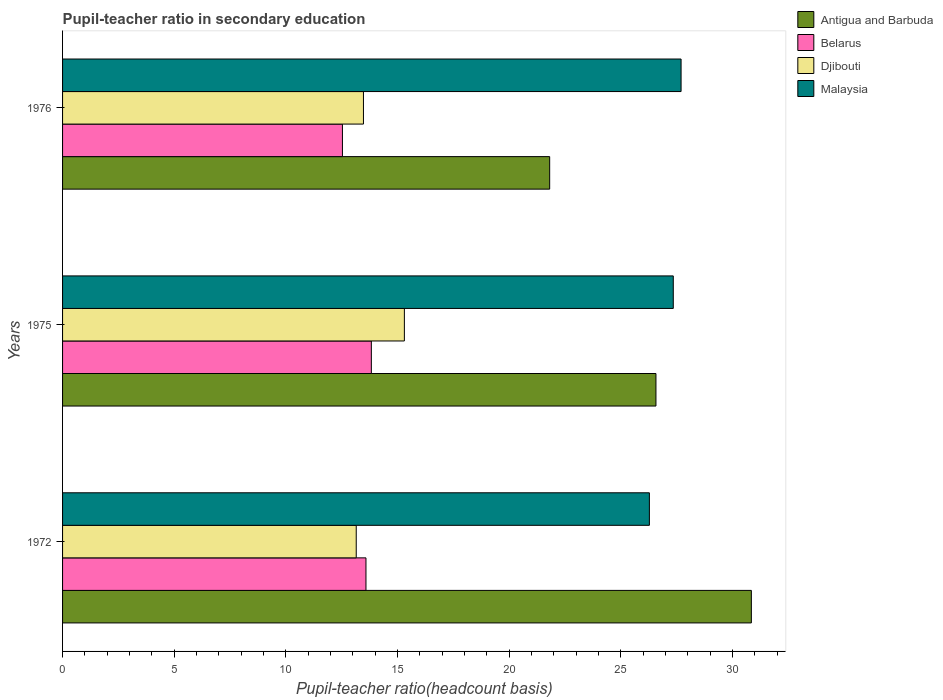Are the number of bars per tick equal to the number of legend labels?
Keep it short and to the point. Yes. Are the number of bars on each tick of the Y-axis equal?
Give a very brief answer. Yes. How many bars are there on the 2nd tick from the top?
Provide a succinct answer. 4. How many bars are there on the 3rd tick from the bottom?
Your response must be concise. 4. What is the label of the 2nd group of bars from the top?
Offer a very short reply. 1975. What is the pupil-teacher ratio in secondary education in Belarus in 1975?
Your answer should be compact. 13.83. Across all years, what is the maximum pupil-teacher ratio in secondary education in Malaysia?
Make the answer very short. 27.7. Across all years, what is the minimum pupil-teacher ratio in secondary education in Malaysia?
Give a very brief answer. 26.28. In which year was the pupil-teacher ratio in secondary education in Malaysia maximum?
Ensure brevity in your answer.  1976. What is the total pupil-teacher ratio in secondary education in Djibouti in the graph?
Provide a short and direct response. 41.93. What is the difference between the pupil-teacher ratio in secondary education in Malaysia in 1975 and that in 1976?
Offer a very short reply. -0.35. What is the difference between the pupil-teacher ratio in secondary education in Antigua and Barbuda in 1975 and the pupil-teacher ratio in secondary education in Djibouti in 1972?
Ensure brevity in your answer.  13.42. What is the average pupil-teacher ratio in secondary education in Malaysia per year?
Provide a short and direct response. 27.11. In the year 1975, what is the difference between the pupil-teacher ratio in secondary education in Belarus and pupil-teacher ratio in secondary education in Djibouti?
Your answer should be very brief. -1.48. What is the ratio of the pupil-teacher ratio in secondary education in Antigua and Barbuda in 1972 to that in 1976?
Offer a very short reply. 1.41. What is the difference between the highest and the second highest pupil-teacher ratio in secondary education in Antigua and Barbuda?
Keep it short and to the point. 4.27. What is the difference between the highest and the lowest pupil-teacher ratio in secondary education in Belarus?
Keep it short and to the point. 1.29. Is the sum of the pupil-teacher ratio in secondary education in Belarus in 1972 and 1975 greater than the maximum pupil-teacher ratio in secondary education in Antigua and Barbuda across all years?
Ensure brevity in your answer.  No. Is it the case that in every year, the sum of the pupil-teacher ratio in secondary education in Antigua and Barbuda and pupil-teacher ratio in secondary education in Malaysia is greater than the sum of pupil-teacher ratio in secondary education in Belarus and pupil-teacher ratio in secondary education in Djibouti?
Offer a very short reply. Yes. What does the 4th bar from the top in 1972 represents?
Make the answer very short. Antigua and Barbuda. What does the 1st bar from the bottom in 1975 represents?
Provide a succinct answer. Antigua and Barbuda. How many bars are there?
Your response must be concise. 12. What is the difference between two consecutive major ticks on the X-axis?
Provide a short and direct response. 5. Are the values on the major ticks of X-axis written in scientific E-notation?
Keep it short and to the point. No. Does the graph contain any zero values?
Offer a very short reply. No. How many legend labels are there?
Your response must be concise. 4. What is the title of the graph?
Provide a short and direct response. Pupil-teacher ratio in secondary education. Does "Uruguay" appear as one of the legend labels in the graph?
Keep it short and to the point. No. What is the label or title of the X-axis?
Your answer should be very brief. Pupil-teacher ratio(headcount basis). What is the Pupil-teacher ratio(headcount basis) of Antigua and Barbuda in 1972?
Provide a succinct answer. 30.84. What is the Pupil-teacher ratio(headcount basis) of Belarus in 1972?
Provide a short and direct response. 13.59. What is the Pupil-teacher ratio(headcount basis) of Djibouti in 1972?
Your answer should be very brief. 13.15. What is the Pupil-teacher ratio(headcount basis) in Malaysia in 1972?
Provide a succinct answer. 26.28. What is the Pupil-teacher ratio(headcount basis) in Antigua and Barbuda in 1975?
Your answer should be very brief. 26.57. What is the Pupil-teacher ratio(headcount basis) in Belarus in 1975?
Offer a terse response. 13.83. What is the Pupil-teacher ratio(headcount basis) of Djibouti in 1975?
Provide a short and direct response. 15.3. What is the Pupil-teacher ratio(headcount basis) of Malaysia in 1975?
Your answer should be very brief. 27.35. What is the Pupil-teacher ratio(headcount basis) of Antigua and Barbuda in 1976?
Give a very brief answer. 21.81. What is the Pupil-teacher ratio(headcount basis) of Belarus in 1976?
Provide a short and direct response. 12.53. What is the Pupil-teacher ratio(headcount basis) of Djibouti in 1976?
Ensure brevity in your answer.  13.47. What is the Pupil-teacher ratio(headcount basis) in Malaysia in 1976?
Provide a short and direct response. 27.7. Across all years, what is the maximum Pupil-teacher ratio(headcount basis) in Antigua and Barbuda?
Ensure brevity in your answer.  30.84. Across all years, what is the maximum Pupil-teacher ratio(headcount basis) of Belarus?
Your answer should be very brief. 13.83. Across all years, what is the maximum Pupil-teacher ratio(headcount basis) in Djibouti?
Your answer should be very brief. 15.3. Across all years, what is the maximum Pupil-teacher ratio(headcount basis) of Malaysia?
Make the answer very short. 27.7. Across all years, what is the minimum Pupil-teacher ratio(headcount basis) of Antigua and Barbuda?
Provide a short and direct response. 21.81. Across all years, what is the minimum Pupil-teacher ratio(headcount basis) of Belarus?
Ensure brevity in your answer.  12.53. Across all years, what is the minimum Pupil-teacher ratio(headcount basis) of Djibouti?
Give a very brief answer. 13.15. Across all years, what is the minimum Pupil-teacher ratio(headcount basis) in Malaysia?
Keep it short and to the point. 26.28. What is the total Pupil-teacher ratio(headcount basis) in Antigua and Barbuda in the graph?
Offer a very short reply. 79.22. What is the total Pupil-teacher ratio(headcount basis) of Belarus in the graph?
Provide a succinct answer. 39.94. What is the total Pupil-teacher ratio(headcount basis) in Djibouti in the graph?
Your answer should be very brief. 41.93. What is the total Pupil-teacher ratio(headcount basis) in Malaysia in the graph?
Your answer should be compact. 81.32. What is the difference between the Pupil-teacher ratio(headcount basis) of Antigua and Barbuda in 1972 and that in 1975?
Offer a very short reply. 4.27. What is the difference between the Pupil-teacher ratio(headcount basis) in Belarus in 1972 and that in 1975?
Give a very brief answer. -0.24. What is the difference between the Pupil-teacher ratio(headcount basis) of Djibouti in 1972 and that in 1975?
Your answer should be compact. -2.15. What is the difference between the Pupil-teacher ratio(headcount basis) in Malaysia in 1972 and that in 1975?
Make the answer very short. -1.07. What is the difference between the Pupil-teacher ratio(headcount basis) of Antigua and Barbuda in 1972 and that in 1976?
Provide a succinct answer. 9.03. What is the difference between the Pupil-teacher ratio(headcount basis) of Belarus in 1972 and that in 1976?
Provide a succinct answer. 1.05. What is the difference between the Pupil-teacher ratio(headcount basis) of Djibouti in 1972 and that in 1976?
Make the answer very short. -0.32. What is the difference between the Pupil-teacher ratio(headcount basis) in Malaysia in 1972 and that in 1976?
Keep it short and to the point. -1.42. What is the difference between the Pupil-teacher ratio(headcount basis) of Antigua and Barbuda in 1975 and that in 1976?
Your answer should be very brief. 4.76. What is the difference between the Pupil-teacher ratio(headcount basis) of Belarus in 1975 and that in 1976?
Your answer should be compact. 1.29. What is the difference between the Pupil-teacher ratio(headcount basis) of Djibouti in 1975 and that in 1976?
Ensure brevity in your answer.  1.83. What is the difference between the Pupil-teacher ratio(headcount basis) of Malaysia in 1975 and that in 1976?
Your response must be concise. -0.35. What is the difference between the Pupil-teacher ratio(headcount basis) in Antigua and Barbuda in 1972 and the Pupil-teacher ratio(headcount basis) in Belarus in 1975?
Offer a terse response. 17.02. What is the difference between the Pupil-teacher ratio(headcount basis) in Antigua and Barbuda in 1972 and the Pupil-teacher ratio(headcount basis) in Djibouti in 1975?
Provide a succinct answer. 15.54. What is the difference between the Pupil-teacher ratio(headcount basis) in Antigua and Barbuda in 1972 and the Pupil-teacher ratio(headcount basis) in Malaysia in 1975?
Provide a short and direct response. 3.5. What is the difference between the Pupil-teacher ratio(headcount basis) of Belarus in 1972 and the Pupil-teacher ratio(headcount basis) of Djibouti in 1975?
Provide a succinct answer. -1.72. What is the difference between the Pupil-teacher ratio(headcount basis) in Belarus in 1972 and the Pupil-teacher ratio(headcount basis) in Malaysia in 1975?
Provide a succinct answer. -13.76. What is the difference between the Pupil-teacher ratio(headcount basis) in Djibouti in 1972 and the Pupil-teacher ratio(headcount basis) in Malaysia in 1975?
Your response must be concise. -14.2. What is the difference between the Pupil-teacher ratio(headcount basis) in Antigua and Barbuda in 1972 and the Pupil-teacher ratio(headcount basis) in Belarus in 1976?
Offer a very short reply. 18.31. What is the difference between the Pupil-teacher ratio(headcount basis) of Antigua and Barbuda in 1972 and the Pupil-teacher ratio(headcount basis) of Djibouti in 1976?
Give a very brief answer. 17.37. What is the difference between the Pupil-teacher ratio(headcount basis) of Antigua and Barbuda in 1972 and the Pupil-teacher ratio(headcount basis) of Malaysia in 1976?
Your answer should be compact. 3.15. What is the difference between the Pupil-teacher ratio(headcount basis) in Belarus in 1972 and the Pupil-teacher ratio(headcount basis) in Djibouti in 1976?
Give a very brief answer. 0.11. What is the difference between the Pupil-teacher ratio(headcount basis) in Belarus in 1972 and the Pupil-teacher ratio(headcount basis) in Malaysia in 1976?
Make the answer very short. -14.11. What is the difference between the Pupil-teacher ratio(headcount basis) in Djibouti in 1972 and the Pupil-teacher ratio(headcount basis) in Malaysia in 1976?
Keep it short and to the point. -14.55. What is the difference between the Pupil-teacher ratio(headcount basis) of Antigua and Barbuda in 1975 and the Pupil-teacher ratio(headcount basis) of Belarus in 1976?
Offer a terse response. 14.04. What is the difference between the Pupil-teacher ratio(headcount basis) in Antigua and Barbuda in 1975 and the Pupil-teacher ratio(headcount basis) in Djibouti in 1976?
Ensure brevity in your answer.  13.1. What is the difference between the Pupil-teacher ratio(headcount basis) of Antigua and Barbuda in 1975 and the Pupil-teacher ratio(headcount basis) of Malaysia in 1976?
Your response must be concise. -1.12. What is the difference between the Pupil-teacher ratio(headcount basis) in Belarus in 1975 and the Pupil-teacher ratio(headcount basis) in Djibouti in 1976?
Provide a succinct answer. 0.35. What is the difference between the Pupil-teacher ratio(headcount basis) in Belarus in 1975 and the Pupil-teacher ratio(headcount basis) in Malaysia in 1976?
Give a very brief answer. -13.87. What is the difference between the Pupil-teacher ratio(headcount basis) of Djibouti in 1975 and the Pupil-teacher ratio(headcount basis) of Malaysia in 1976?
Ensure brevity in your answer.  -12.39. What is the average Pupil-teacher ratio(headcount basis) in Antigua and Barbuda per year?
Provide a short and direct response. 26.41. What is the average Pupil-teacher ratio(headcount basis) in Belarus per year?
Keep it short and to the point. 13.31. What is the average Pupil-teacher ratio(headcount basis) in Djibouti per year?
Offer a terse response. 13.98. What is the average Pupil-teacher ratio(headcount basis) of Malaysia per year?
Ensure brevity in your answer.  27.11. In the year 1972, what is the difference between the Pupil-teacher ratio(headcount basis) of Antigua and Barbuda and Pupil-teacher ratio(headcount basis) of Belarus?
Offer a terse response. 17.26. In the year 1972, what is the difference between the Pupil-teacher ratio(headcount basis) in Antigua and Barbuda and Pupil-teacher ratio(headcount basis) in Djibouti?
Your answer should be compact. 17.69. In the year 1972, what is the difference between the Pupil-teacher ratio(headcount basis) in Antigua and Barbuda and Pupil-teacher ratio(headcount basis) in Malaysia?
Ensure brevity in your answer.  4.57. In the year 1972, what is the difference between the Pupil-teacher ratio(headcount basis) of Belarus and Pupil-teacher ratio(headcount basis) of Djibouti?
Make the answer very short. 0.44. In the year 1972, what is the difference between the Pupil-teacher ratio(headcount basis) of Belarus and Pupil-teacher ratio(headcount basis) of Malaysia?
Ensure brevity in your answer.  -12.69. In the year 1972, what is the difference between the Pupil-teacher ratio(headcount basis) in Djibouti and Pupil-teacher ratio(headcount basis) in Malaysia?
Offer a terse response. -13.13. In the year 1975, what is the difference between the Pupil-teacher ratio(headcount basis) of Antigua and Barbuda and Pupil-teacher ratio(headcount basis) of Belarus?
Offer a terse response. 12.74. In the year 1975, what is the difference between the Pupil-teacher ratio(headcount basis) in Antigua and Barbuda and Pupil-teacher ratio(headcount basis) in Djibouti?
Your answer should be compact. 11.27. In the year 1975, what is the difference between the Pupil-teacher ratio(headcount basis) in Antigua and Barbuda and Pupil-teacher ratio(headcount basis) in Malaysia?
Your answer should be compact. -0.78. In the year 1975, what is the difference between the Pupil-teacher ratio(headcount basis) in Belarus and Pupil-teacher ratio(headcount basis) in Djibouti?
Give a very brief answer. -1.48. In the year 1975, what is the difference between the Pupil-teacher ratio(headcount basis) of Belarus and Pupil-teacher ratio(headcount basis) of Malaysia?
Provide a succinct answer. -13.52. In the year 1975, what is the difference between the Pupil-teacher ratio(headcount basis) in Djibouti and Pupil-teacher ratio(headcount basis) in Malaysia?
Provide a succinct answer. -12.04. In the year 1976, what is the difference between the Pupil-teacher ratio(headcount basis) in Antigua and Barbuda and Pupil-teacher ratio(headcount basis) in Belarus?
Your answer should be compact. 9.28. In the year 1976, what is the difference between the Pupil-teacher ratio(headcount basis) of Antigua and Barbuda and Pupil-teacher ratio(headcount basis) of Djibouti?
Provide a succinct answer. 8.34. In the year 1976, what is the difference between the Pupil-teacher ratio(headcount basis) of Antigua and Barbuda and Pupil-teacher ratio(headcount basis) of Malaysia?
Offer a terse response. -5.88. In the year 1976, what is the difference between the Pupil-teacher ratio(headcount basis) of Belarus and Pupil-teacher ratio(headcount basis) of Djibouti?
Your response must be concise. -0.94. In the year 1976, what is the difference between the Pupil-teacher ratio(headcount basis) of Belarus and Pupil-teacher ratio(headcount basis) of Malaysia?
Ensure brevity in your answer.  -15.16. In the year 1976, what is the difference between the Pupil-teacher ratio(headcount basis) of Djibouti and Pupil-teacher ratio(headcount basis) of Malaysia?
Provide a short and direct response. -14.22. What is the ratio of the Pupil-teacher ratio(headcount basis) in Antigua and Barbuda in 1972 to that in 1975?
Ensure brevity in your answer.  1.16. What is the ratio of the Pupil-teacher ratio(headcount basis) of Belarus in 1972 to that in 1975?
Your answer should be very brief. 0.98. What is the ratio of the Pupil-teacher ratio(headcount basis) in Djibouti in 1972 to that in 1975?
Provide a succinct answer. 0.86. What is the ratio of the Pupil-teacher ratio(headcount basis) in Malaysia in 1972 to that in 1975?
Offer a very short reply. 0.96. What is the ratio of the Pupil-teacher ratio(headcount basis) in Antigua and Barbuda in 1972 to that in 1976?
Offer a terse response. 1.41. What is the ratio of the Pupil-teacher ratio(headcount basis) of Belarus in 1972 to that in 1976?
Provide a short and direct response. 1.08. What is the ratio of the Pupil-teacher ratio(headcount basis) of Djibouti in 1972 to that in 1976?
Provide a succinct answer. 0.98. What is the ratio of the Pupil-teacher ratio(headcount basis) of Malaysia in 1972 to that in 1976?
Keep it short and to the point. 0.95. What is the ratio of the Pupil-teacher ratio(headcount basis) of Antigua and Barbuda in 1975 to that in 1976?
Offer a very short reply. 1.22. What is the ratio of the Pupil-teacher ratio(headcount basis) of Belarus in 1975 to that in 1976?
Your answer should be compact. 1.1. What is the ratio of the Pupil-teacher ratio(headcount basis) in Djibouti in 1975 to that in 1976?
Keep it short and to the point. 1.14. What is the ratio of the Pupil-teacher ratio(headcount basis) of Malaysia in 1975 to that in 1976?
Your answer should be very brief. 0.99. What is the difference between the highest and the second highest Pupil-teacher ratio(headcount basis) in Antigua and Barbuda?
Offer a very short reply. 4.27. What is the difference between the highest and the second highest Pupil-teacher ratio(headcount basis) in Belarus?
Offer a terse response. 0.24. What is the difference between the highest and the second highest Pupil-teacher ratio(headcount basis) of Djibouti?
Your answer should be compact. 1.83. What is the difference between the highest and the second highest Pupil-teacher ratio(headcount basis) in Malaysia?
Give a very brief answer. 0.35. What is the difference between the highest and the lowest Pupil-teacher ratio(headcount basis) in Antigua and Barbuda?
Provide a short and direct response. 9.03. What is the difference between the highest and the lowest Pupil-teacher ratio(headcount basis) of Belarus?
Make the answer very short. 1.29. What is the difference between the highest and the lowest Pupil-teacher ratio(headcount basis) of Djibouti?
Make the answer very short. 2.15. What is the difference between the highest and the lowest Pupil-teacher ratio(headcount basis) of Malaysia?
Give a very brief answer. 1.42. 